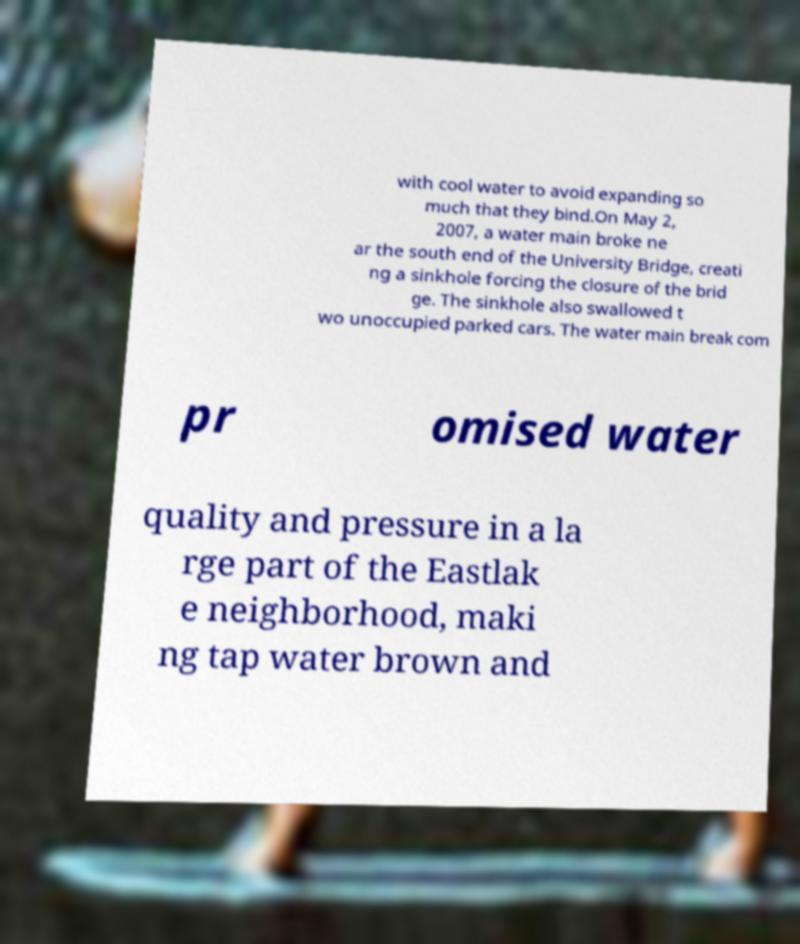I need the written content from this picture converted into text. Can you do that? with cool water to avoid expanding so much that they bind.On May 2, 2007, a water main broke ne ar the south end of the University Bridge, creati ng a sinkhole forcing the closure of the brid ge. The sinkhole also swallowed t wo unoccupied parked cars. The water main break com pr omised water quality and pressure in a la rge part of the Eastlak e neighborhood, maki ng tap water brown and 